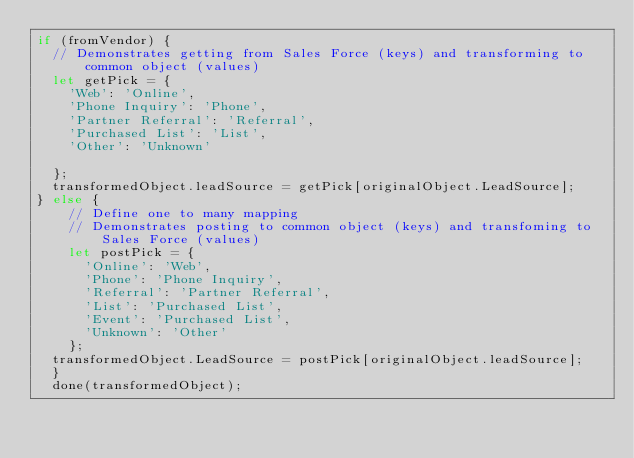<code> <loc_0><loc_0><loc_500><loc_500><_JavaScript_>if (fromVendor) {
  // Demonstrates getting from Sales Force (keys) and transforming to common object (values)
  let getPick = {
    'Web': 'Online',
    'Phone Inquiry': 'Phone',
    'Partner Referral': 'Referral',
    'Purchased List': 'List',
    'Other': 'Unknown'
    
  };
  transformedObject.leadSource = getPick[originalObject.LeadSource];
} else {
    // Define one to many mapping
    // Demonstrates posting to common object (keys) and transfoming to Sales Force (values)
    let postPick = {
      'Online': 'Web',
      'Phone': 'Phone Inquiry',
      'Referral': 'Partner Referral',
      'List': 'Purchased List',
      'Event': 'Purchased List',
      'Unknown': 'Other'
    };
  transformedObject.LeadSource = postPick[originalObject.leadSource];
  }
  done(transformedObject);</code> 